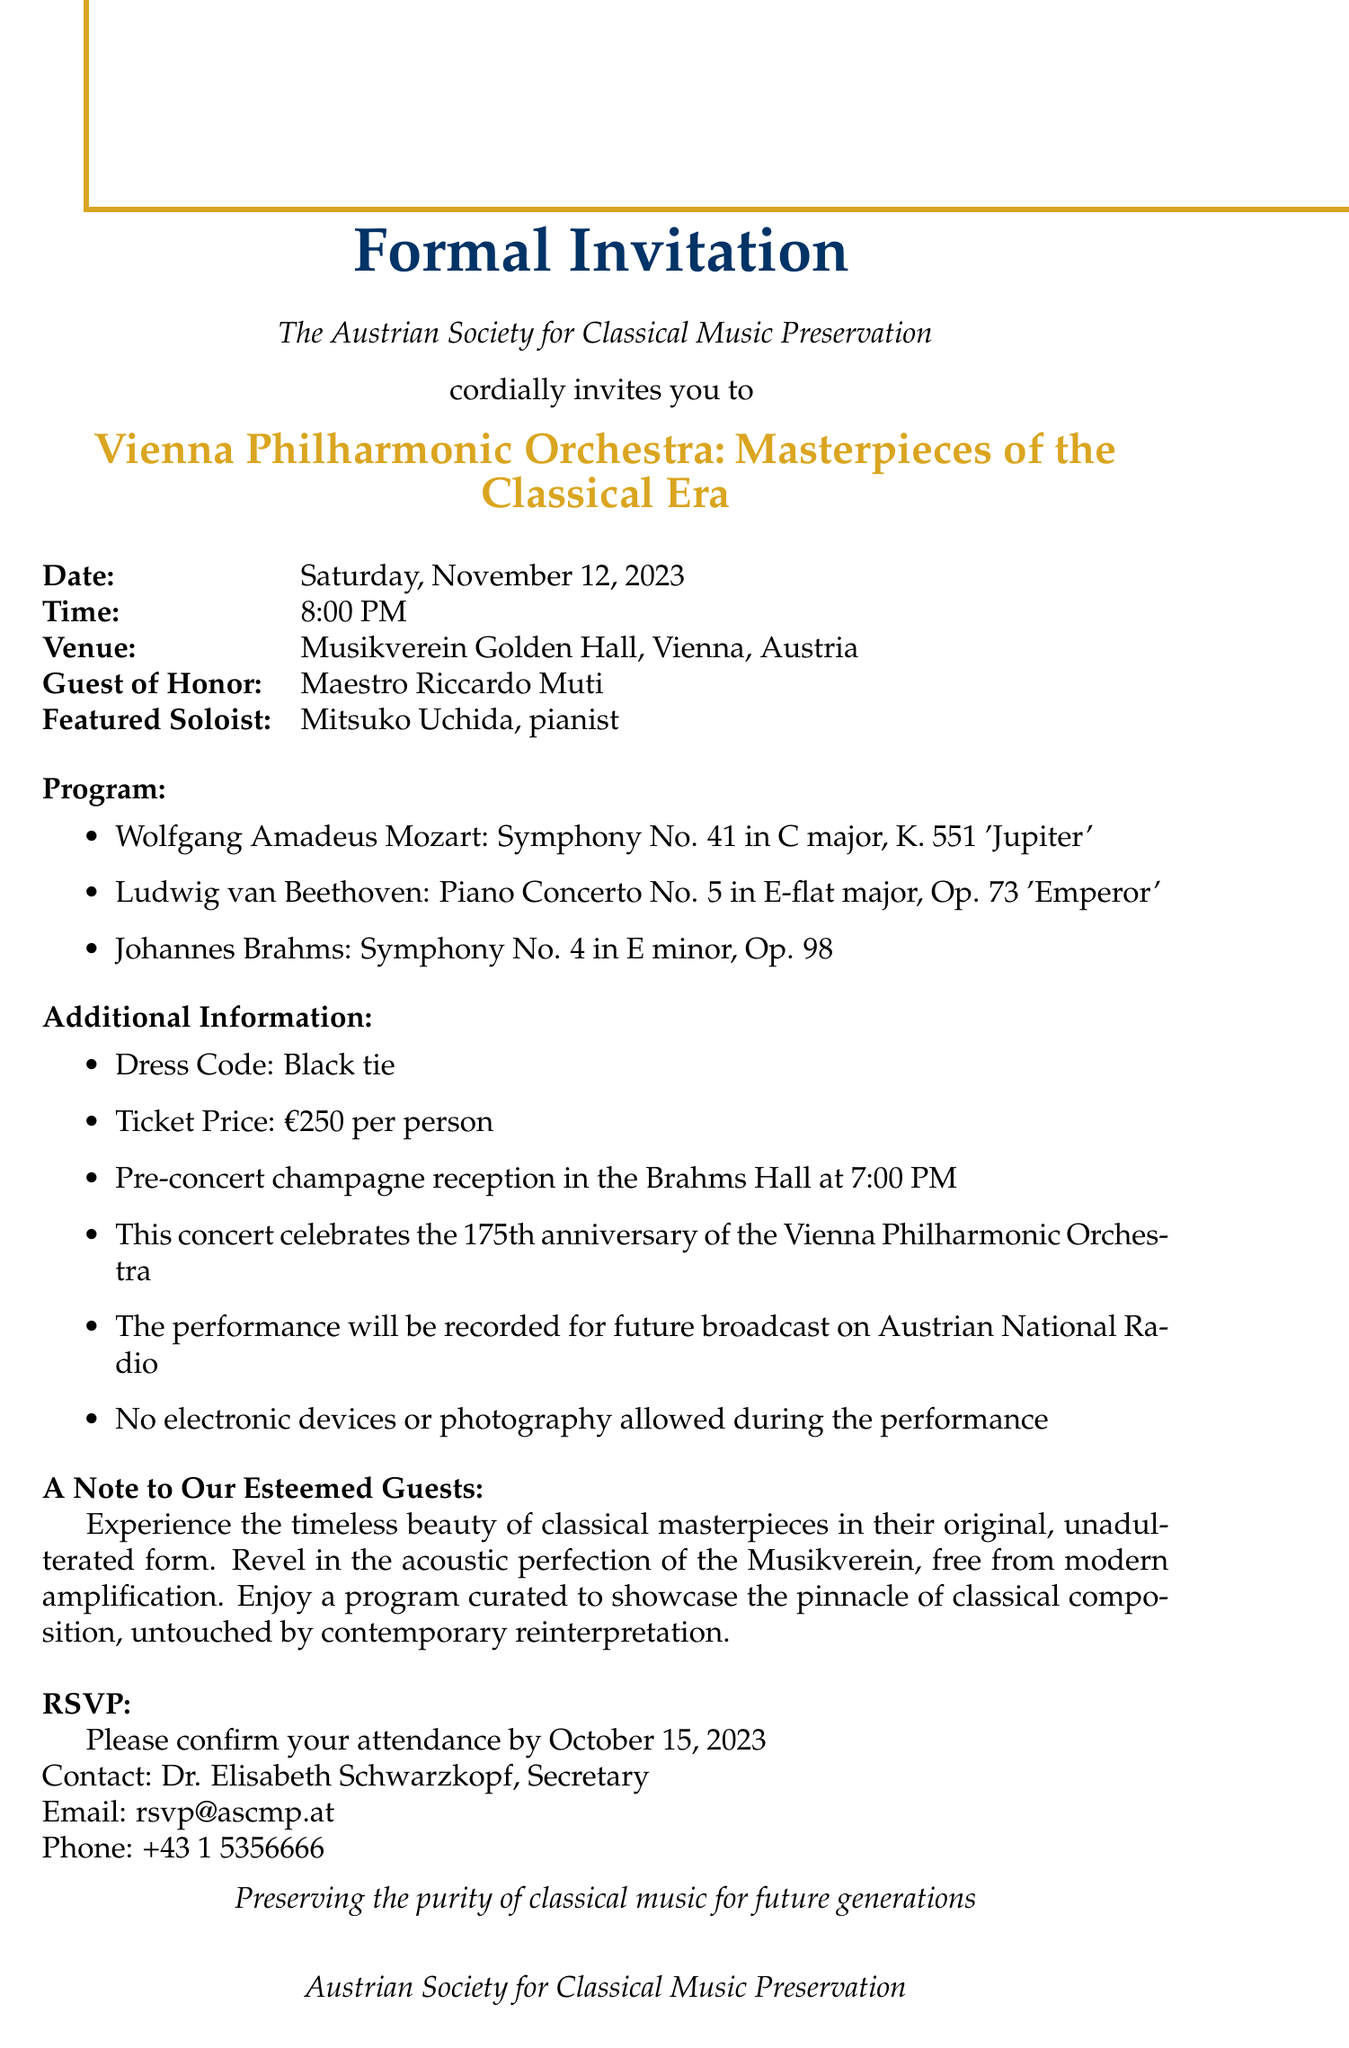What is the name of the orchestra performing at the concert? The document specifies that it is the Vienna Philharmonic Orchestra.
Answer: Vienna Philharmonic Orchestra What is the date of the concert? The invitation states that the concert is scheduled for Saturday, November 12, 2023.
Answer: Saturday, November 12, 2023 Who is the guest of honor for the event? The document indicates that the guest of honor is Maestro Riccardo Muti.
Answer: Maestro Riccardo Muti What is the ticket price per person? According to the document, the ticket price is €250 per person.
Answer: €250 per person What is the dress code for the event? The invitation mentions that the dress code is black tie.
Answer: Black tie What is the purpose of this concert? The text indicates that the concert celebrates the 175th anniversary of the Vienna Philharmonic Orchestra.
Answer: 175th anniversary What will happen before the concert? The document states that there will be a pre-concert champagne reception in the Brahms Hall at 7:00 PM.
Answer: Pre-concert champagne reception Are electronic devices allowed during the performance? The document clearly states that no electronic devices or photography are allowed during the performance.
Answer: No What type of music will be performed? The concert will feature masterpieces of the classical era, as indicated in the title.
Answer: Classical masterpieces 